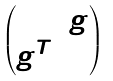Convert formula to latex. <formula><loc_0><loc_0><loc_500><loc_500>\begin{pmatrix} 0 & g \\ g ^ { T } & 0 \end{pmatrix}</formula> 